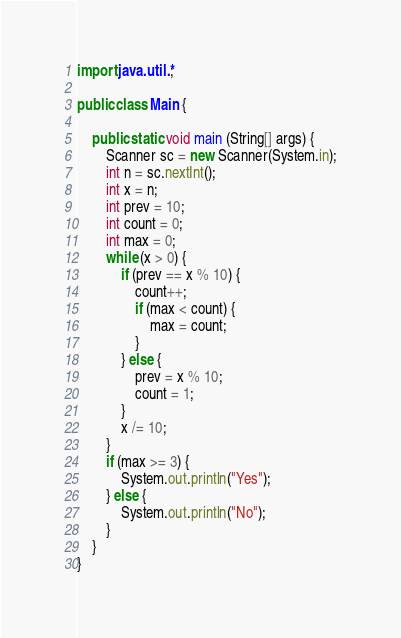Convert code to text. <code><loc_0><loc_0><loc_500><loc_500><_Java_>import java.util.*;

public class Main {

	public static void main (String[] args) {
		Scanner sc = new Scanner(System.in);
		int n = sc.nextInt();
		int x = n;
		int prev = 10;
		int count = 0;
		int max = 0;
		while (x > 0) {
			if (prev == x % 10) {
				count++;
				if (max < count) {
					max = count;
				}
			} else {
				prev = x % 10;
				count = 1;
			}
			x /= 10;
		}
		if (max >= 3) {
			System.out.println("Yes");
		} else {
			System.out.println("No");
		}
	}
}
</code> 